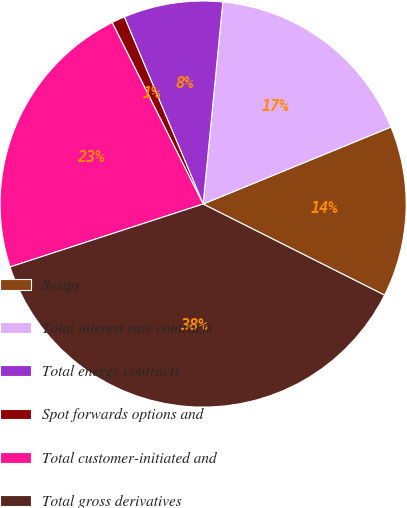<chart> <loc_0><loc_0><loc_500><loc_500><pie_chart><fcel>Swaps<fcel>Total interest rate contracts<fcel>Total energy contracts<fcel>Spot forwards options and<fcel>Total customer-initiated and<fcel>Total gross derivatives<nl><fcel>13.6%<fcel>17.26%<fcel>7.89%<fcel>1.05%<fcel>22.62%<fcel>37.58%<nl></chart> 